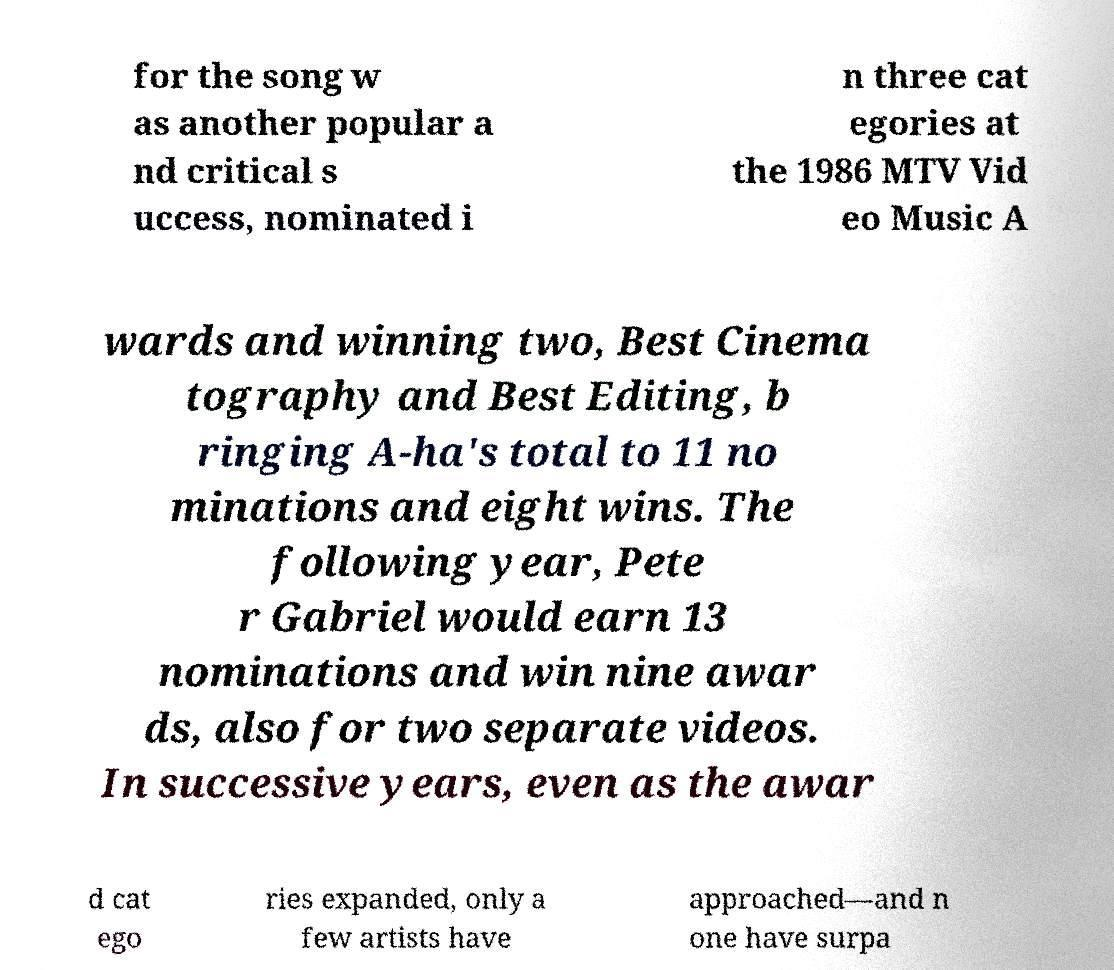Could you assist in decoding the text presented in this image and type it out clearly? for the song w as another popular a nd critical s uccess, nominated i n three cat egories at the 1986 MTV Vid eo Music A wards and winning two, Best Cinema tography and Best Editing, b ringing A-ha's total to 11 no minations and eight wins. The following year, Pete r Gabriel would earn 13 nominations and win nine awar ds, also for two separate videos. In successive years, even as the awar d cat ego ries expanded, only a few artists have approached—and n one have surpa 